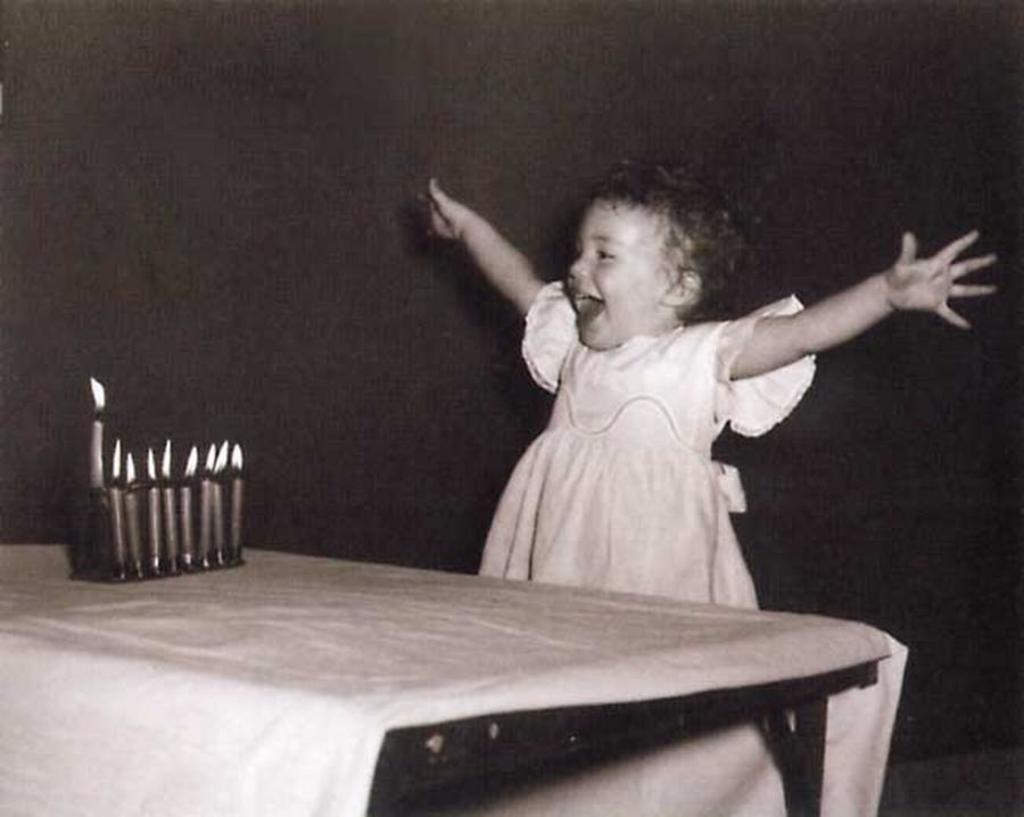What is the main subject of the image? The main subject of the image is a girl. What is the girl doing in the image? The girl is standing and laughing. What objects can be seen on a table in the image? There are candles on a table in the image. What type of powder is the girl offering to the boy in the image? There is no boy present in the image, and the girl is not offering any powder. 